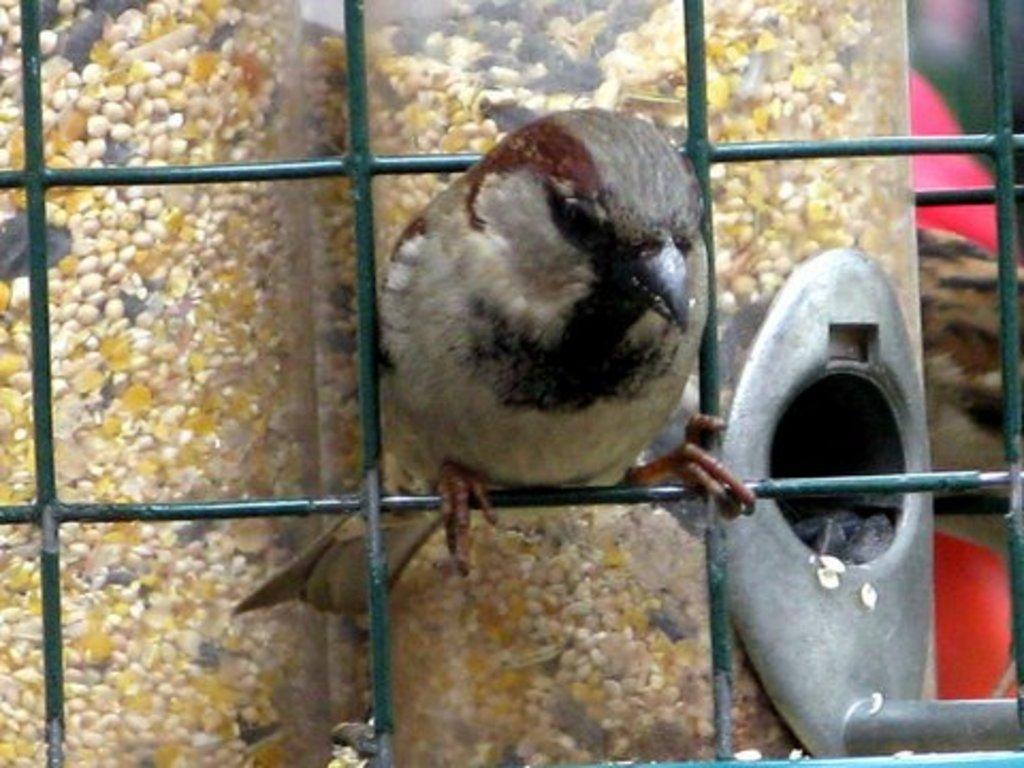Please provide a concise description of this image. In the middle of this image, there is a bird standing on a green color fence. In the background, there are seeds and other objects. 